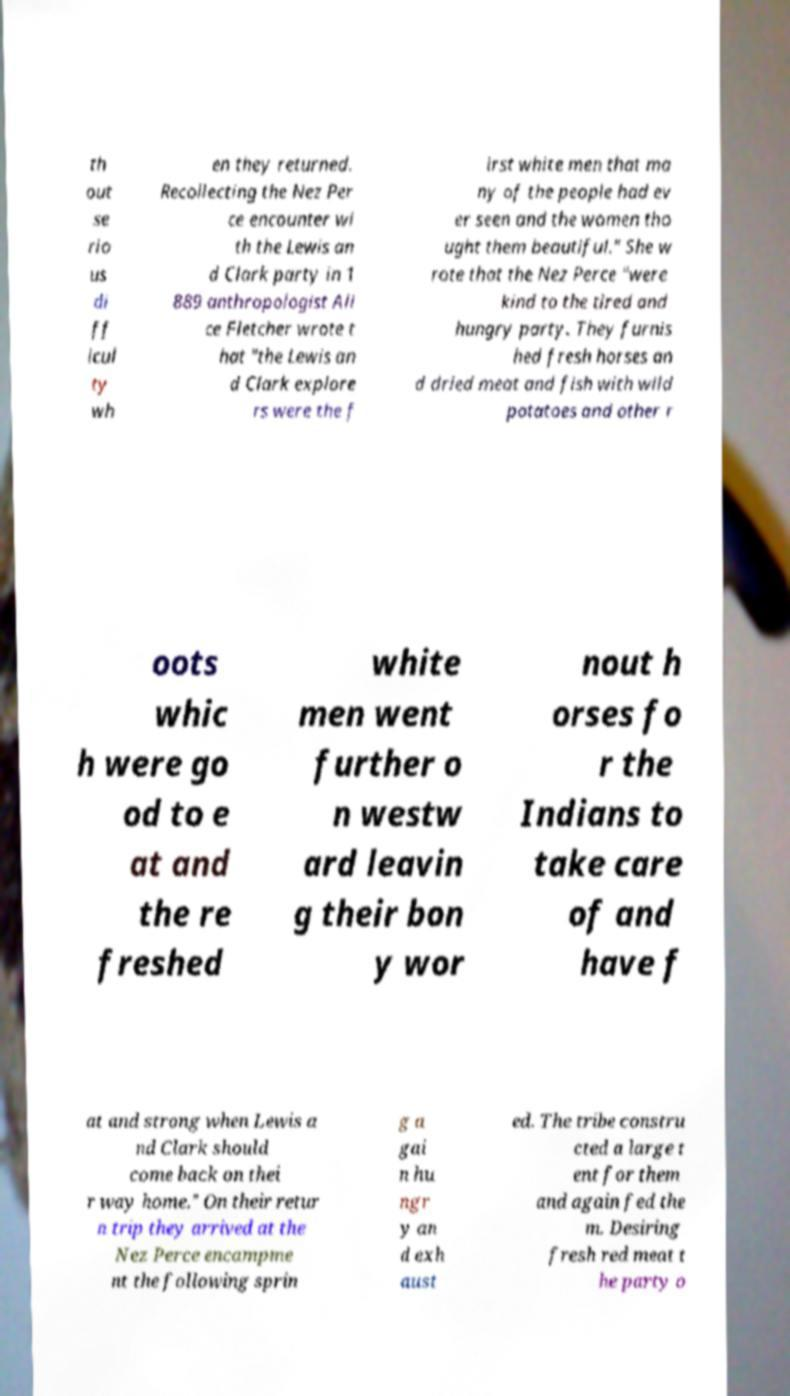For documentation purposes, I need the text within this image transcribed. Could you provide that? th out se rio us di ff icul ty wh en they returned. Recollecting the Nez Per ce encounter wi th the Lewis an d Clark party in 1 889 anthropologist Ali ce Fletcher wrote t hat "the Lewis an d Clark explore rs were the f irst white men that ma ny of the people had ev er seen and the women tho ught them beautiful." She w rote that the Nez Perce "were kind to the tired and hungry party. They furnis hed fresh horses an d dried meat and fish with wild potatoes and other r oots whic h were go od to e at and the re freshed white men went further o n westw ard leavin g their bon y wor nout h orses fo r the Indians to take care of and have f at and strong when Lewis a nd Clark should come back on thei r way home." On their retur n trip they arrived at the Nez Perce encampme nt the following sprin g a gai n hu ngr y an d exh aust ed. The tribe constru cted a large t ent for them and again fed the m. Desiring fresh red meat t he party o 